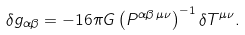<formula> <loc_0><loc_0><loc_500><loc_500>\delta g _ { \alpha \beta } = - 1 6 \pi G \left ( P ^ { \alpha \beta \, \mu \nu } \right ) ^ { - 1 } \delta T ^ { \mu \nu } .</formula> 